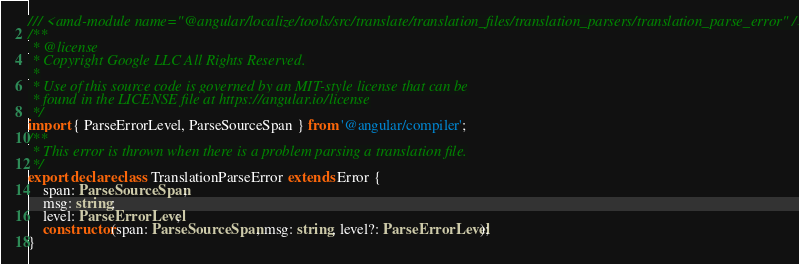Convert code to text. <code><loc_0><loc_0><loc_500><loc_500><_TypeScript_>/// <amd-module name="@angular/localize/tools/src/translate/translation_files/translation_parsers/translation_parse_error" />
/**
 * @license
 * Copyright Google LLC All Rights Reserved.
 *
 * Use of this source code is governed by an MIT-style license that can be
 * found in the LICENSE file at https://angular.io/license
 */
import { ParseErrorLevel, ParseSourceSpan } from '@angular/compiler';
/**
 * This error is thrown when there is a problem parsing a translation file.
 */
export declare class TranslationParseError extends Error {
    span: ParseSourceSpan;
    msg: string;
    level: ParseErrorLevel;
    constructor(span: ParseSourceSpan, msg: string, level?: ParseErrorLevel);
}
</code> 